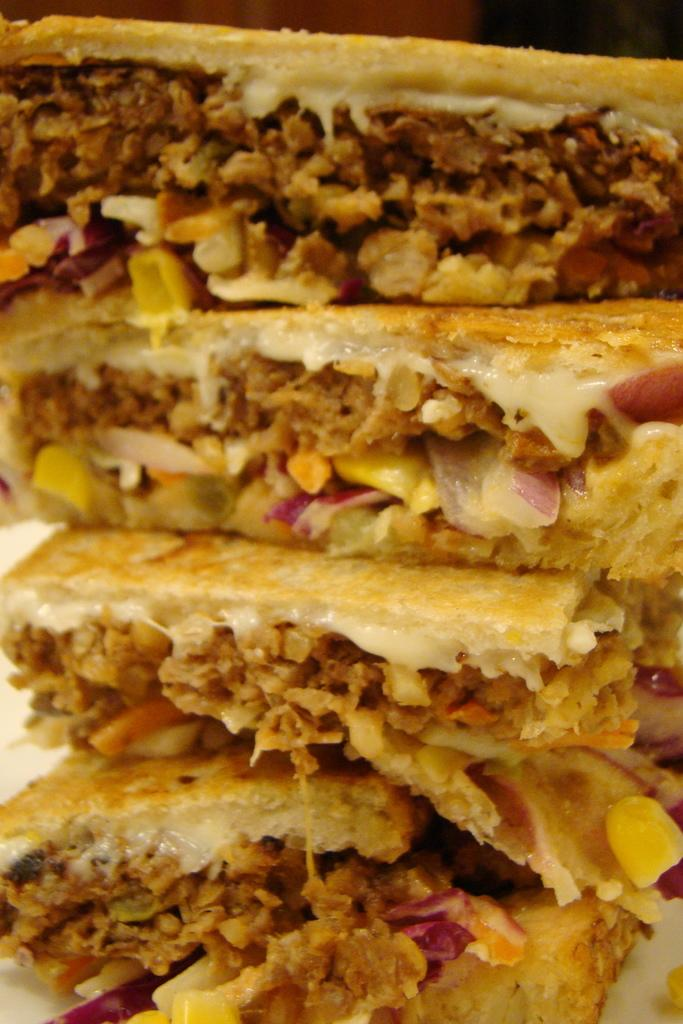What type of food can be seen in the image? There are sandwiches in the image. What is inside the sandwiches? The sandwiches have stuffings. How are the sandwiches arranged in the image? The sandwiches are placed on a plate. What type of vegetable is being used as a card in the image? There is no vegetable being used as a card in the image; the image only features sandwiches. 